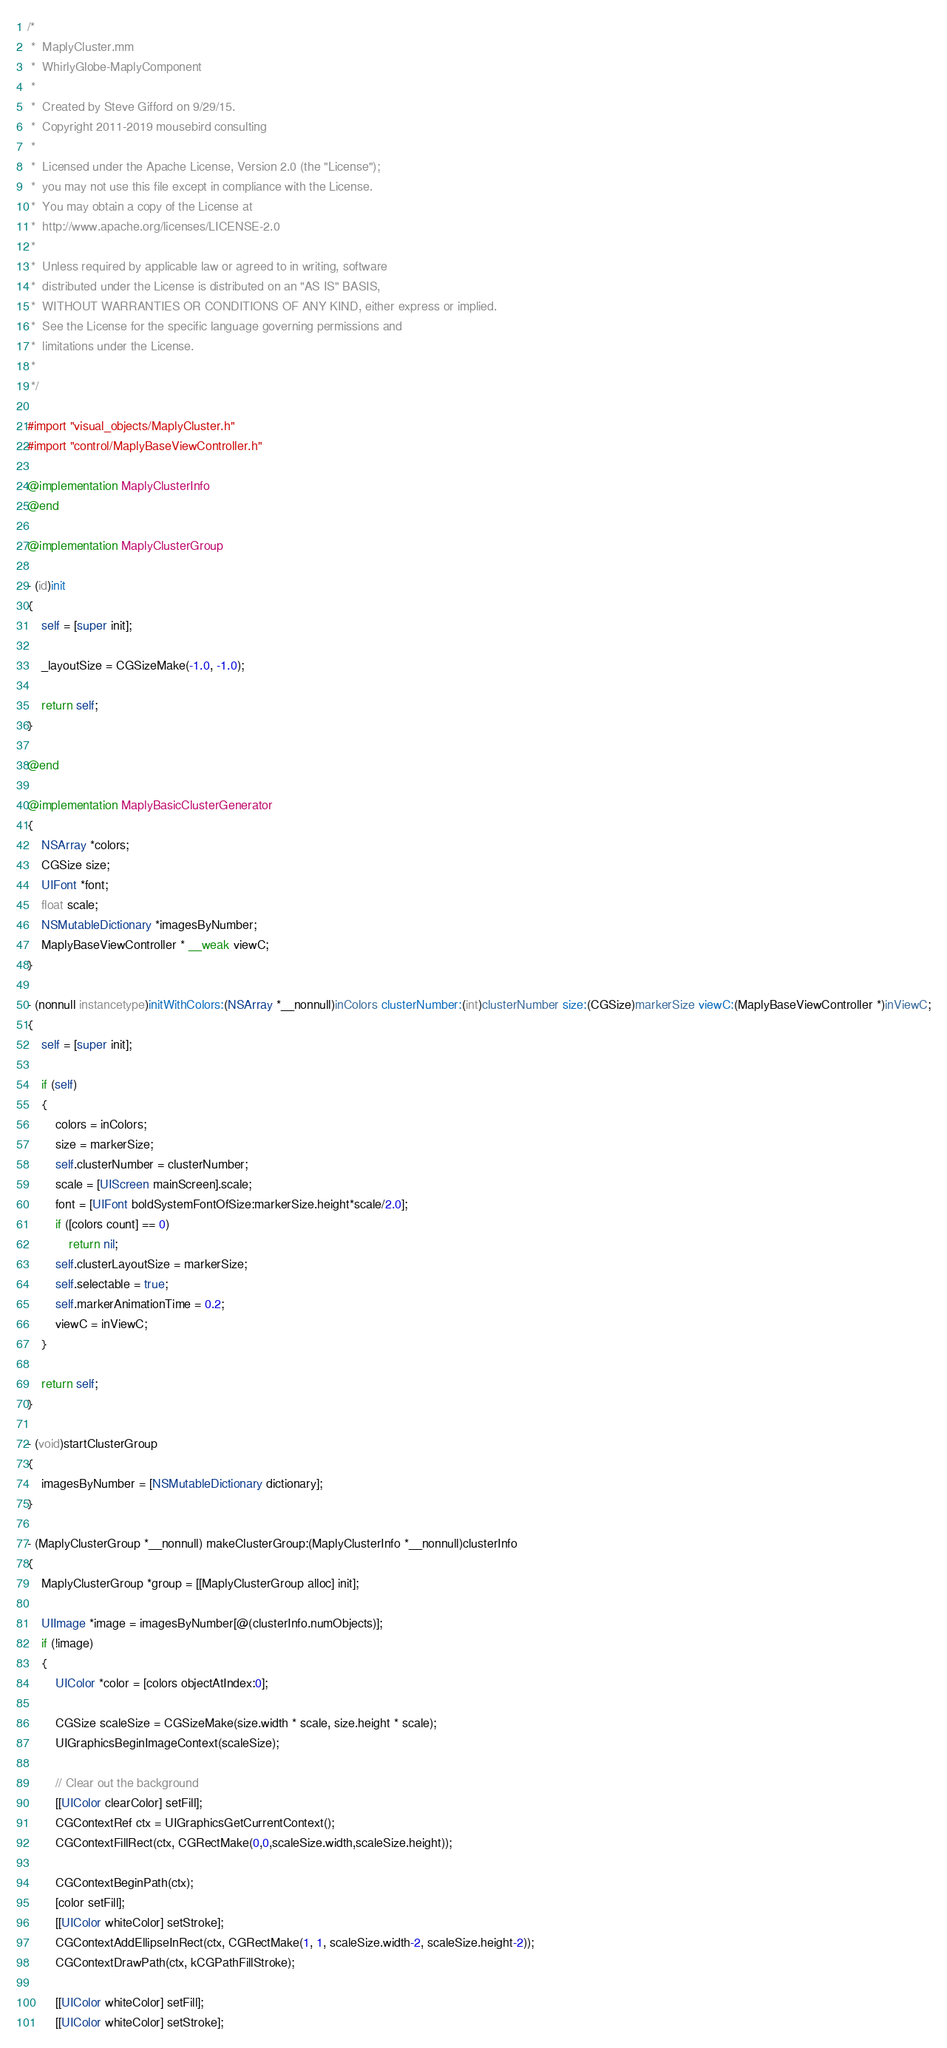<code> <loc_0><loc_0><loc_500><loc_500><_ObjectiveC_>/*
 *  MaplyCluster.mm
 *  WhirlyGlobe-MaplyComponent
 *
 *  Created by Steve Gifford on 9/29/15.
 *  Copyright 2011-2019 mousebird consulting
 *
 *  Licensed under the Apache License, Version 2.0 (the "License");
 *  you may not use this file except in compliance with the License.
 *  You may obtain a copy of the License at
 *  http://www.apache.org/licenses/LICENSE-2.0
 *
 *  Unless required by applicable law or agreed to in writing, software
 *  distributed under the License is distributed on an "AS IS" BASIS,
 *  WITHOUT WARRANTIES OR CONDITIONS OF ANY KIND, either express or implied.
 *  See the License for the specific language governing permissions and
 *  limitations under the License.
 *
 */

#import "visual_objects/MaplyCluster.h"
#import "control/MaplyBaseViewController.h"

@implementation MaplyClusterInfo
@end

@implementation MaplyClusterGroup

- (id)init
{
    self = [super init];
    
    _layoutSize = CGSizeMake(-1.0, -1.0);
    
    return self;
}

@end

@implementation MaplyBasicClusterGenerator
{
    NSArray *colors;
    CGSize size;
    UIFont *font;
    float scale;
    NSMutableDictionary *imagesByNumber;
    MaplyBaseViewController * __weak viewC;
}

- (nonnull instancetype)initWithColors:(NSArray *__nonnull)inColors clusterNumber:(int)clusterNumber size:(CGSize)markerSize viewC:(MaplyBaseViewController *)inViewC;
{
    self = [super init];

    if (self)
    {
        colors = inColors;
        size = markerSize;
        self.clusterNumber = clusterNumber;
        scale = [UIScreen mainScreen].scale;
        font = [UIFont boldSystemFontOfSize:markerSize.height*scale/2.0];
        if ([colors count] == 0)
            return nil;
        self.clusterLayoutSize = markerSize;
        self.selectable = true;
        self.markerAnimationTime = 0.2;
        viewC = inViewC;
    }
    
    return self;
}

- (void)startClusterGroup
{
    imagesByNumber = [NSMutableDictionary dictionary];    
}

- (MaplyClusterGroup *__nonnull) makeClusterGroup:(MaplyClusterInfo *__nonnull)clusterInfo
{
    MaplyClusterGroup *group = [[MaplyClusterGroup alloc] init];
    
    UIImage *image = imagesByNumber[@(clusterInfo.numObjects)];
    if (!image)
    {
        UIColor *color = [colors objectAtIndex:0];
        
        CGSize scaleSize = CGSizeMake(size.width * scale, size.height * scale);
        UIGraphicsBeginImageContext(scaleSize);
        
        // Clear out the background
        [[UIColor clearColor] setFill];
        CGContextRef ctx = UIGraphicsGetCurrentContext();
        CGContextFillRect(ctx, CGRectMake(0,0,scaleSize.width,scaleSize.height));

        CGContextBeginPath(ctx);
        [color setFill];
        [[UIColor whiteColor] setStroke];
        CGContextAddEllipseInRect(ctx, CGRectMake(1, 1, scaleSize.width-2, scaleSize.height-2));
        CGContextDrawPath(ctx, kCGPathFillStroke);
        
        [[UIColor whiteColor] setFill];
        [[UIColor whiteColor] setStroke];</code> 